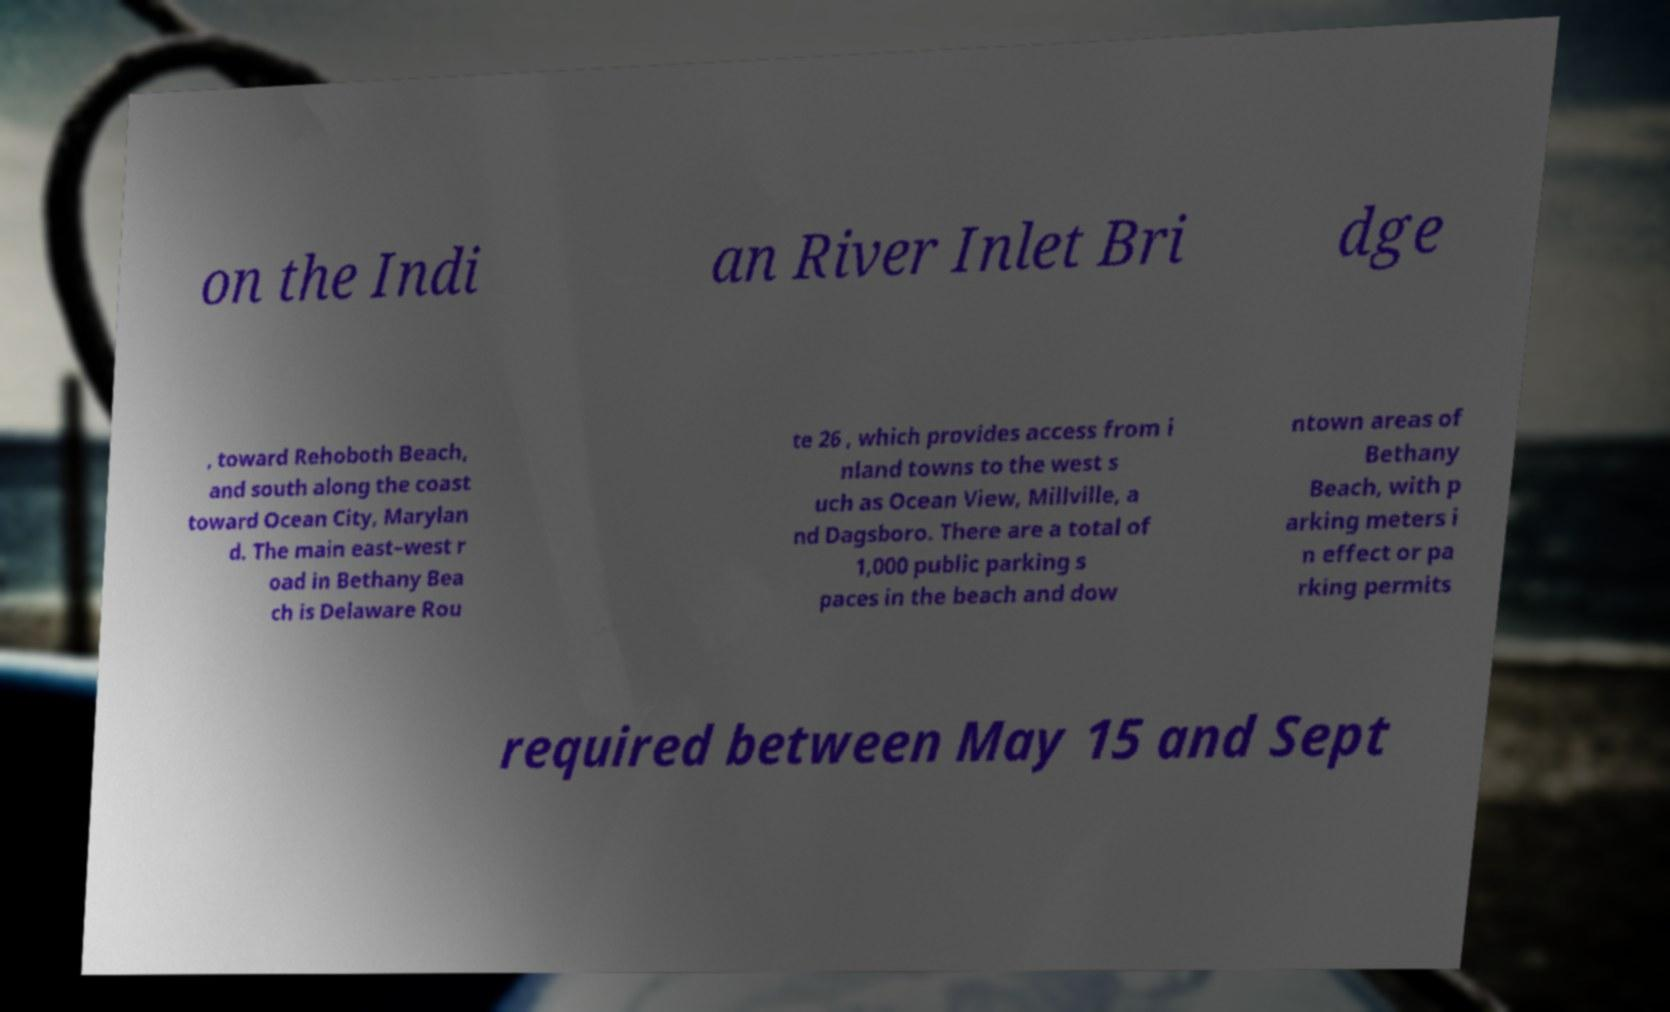Could you assist in decoding the text presented in this image and type it out clearly? on the Indi an River Inlet Bri dge , toward Rehoboth Beach, and south along the coast toward Ocean City, Marylan d. The main east–west r oad in Bethany Bea ch is Delaware Rou te 26 , which provides access from i nland towns to the west s uch as Ocean View, Millville, a nd Dagsboro. There are a total of 1,000 public parking s paces in the beach and dow ntown areas of Bethany Beach, with p arking meters i n effect or pa rking permits required between May 15 and Sept 